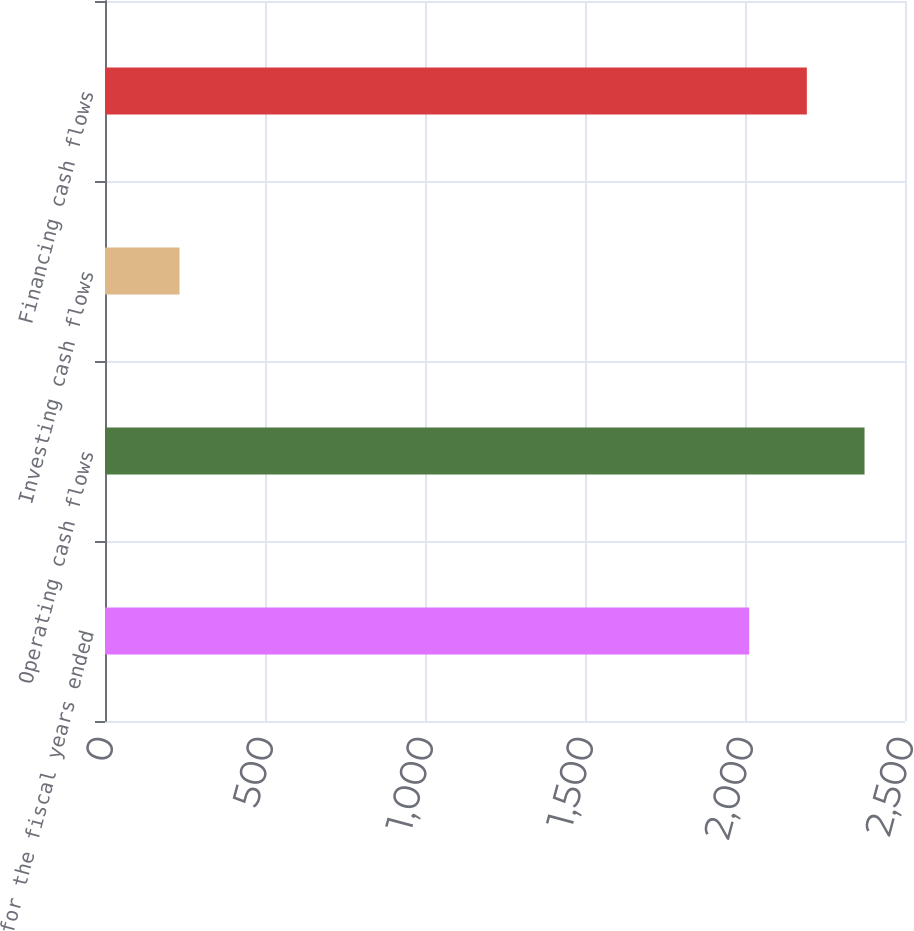<chart> <loc_0><loc_0><loc_500><loc_500><bar_chart><fcel>for the fiscal years ended<fcel>Operating cash flows<fcel>Investing cash flows<fcel>Financing cash flows<nl><fcel>2013<fcel>2373.56<fcel>232.9<fcel>2193.28<nl></chart> 